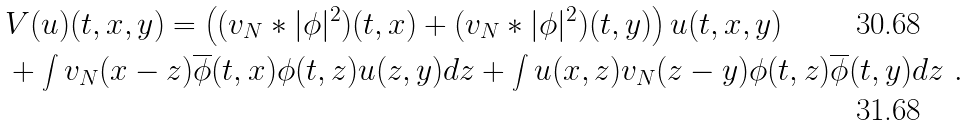Convert formula to latex. <formula><loc_0><loc_0><loc_500><loc_500>& V ( u ) ( t , x , y ) = \left ( ( v _ { N } * | \phi | ^ { 2 } ) ( t , x ) + ( v _ { N } * | \phi | ^ { 2 } ) ( t , y ) \right ) u ( t , x , y ) \\ & + \int v _ { N } ( x - z ) \overline { \phi } ( t , x ) \phi ( t , z ) u ( z , y ) d z + \int u ( x , z ) v _ { N } ( z - y ) \phi ( t , z ) \overline { \phi } ( t , y ) d z \ .</formula> 